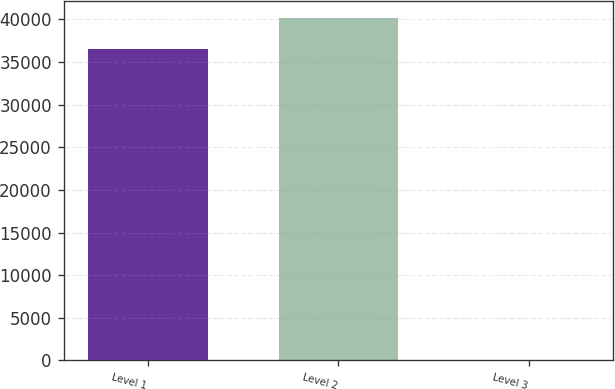<chart> <loc_0><loc_0><loc_500><loc_500><bar_chart><fcel>Level 1<fcel>Level 2<fcel>Level 3<nl><fcel>36468<fcel>40114.7<fcel>1.49<nl></chart> 